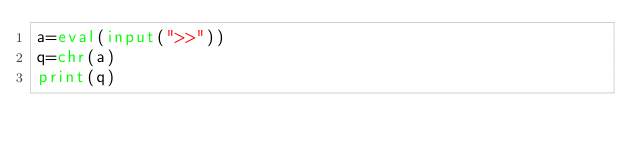<code> <loc_0><loc_0><loc_500><loc_500><_Python_>a=eval(input(">>"))
q=chr(a)
print(q)
</code> 